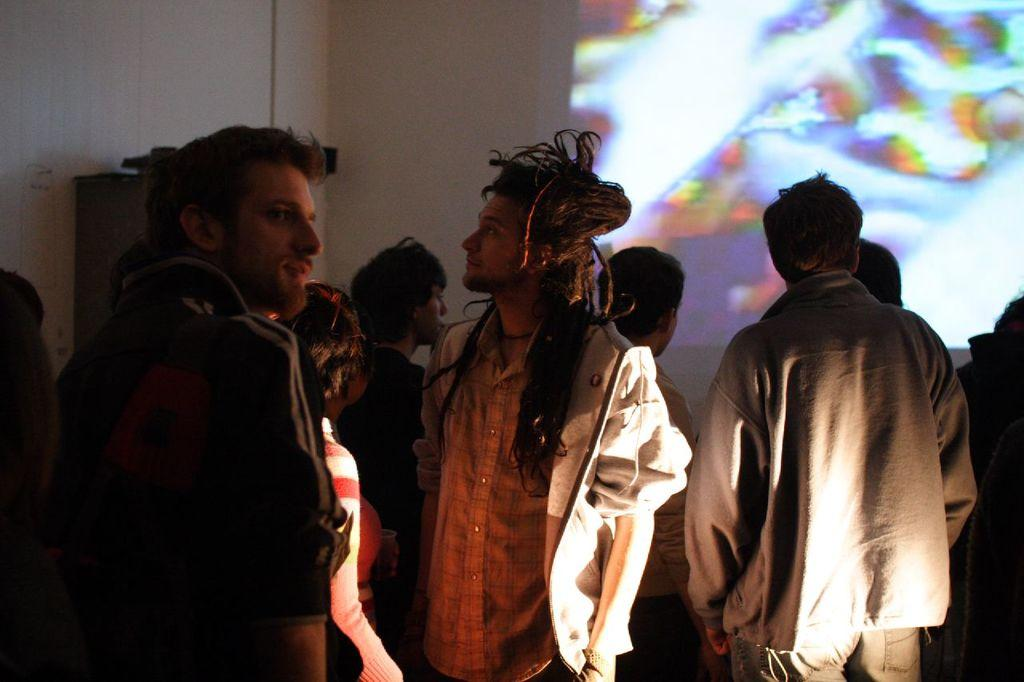What is happening in the image? There are people standing in the image. What can be seen on the wall in the background of the image? There is a screen on the wall in the background of the image. Can you describe the object visible in the background of the image? Unfortunately, the provided facts do not give enough information to describe the object in the background. How many children are reading books in the image? There is no mention of children or books in the image, so it is not possible to answer this question. 